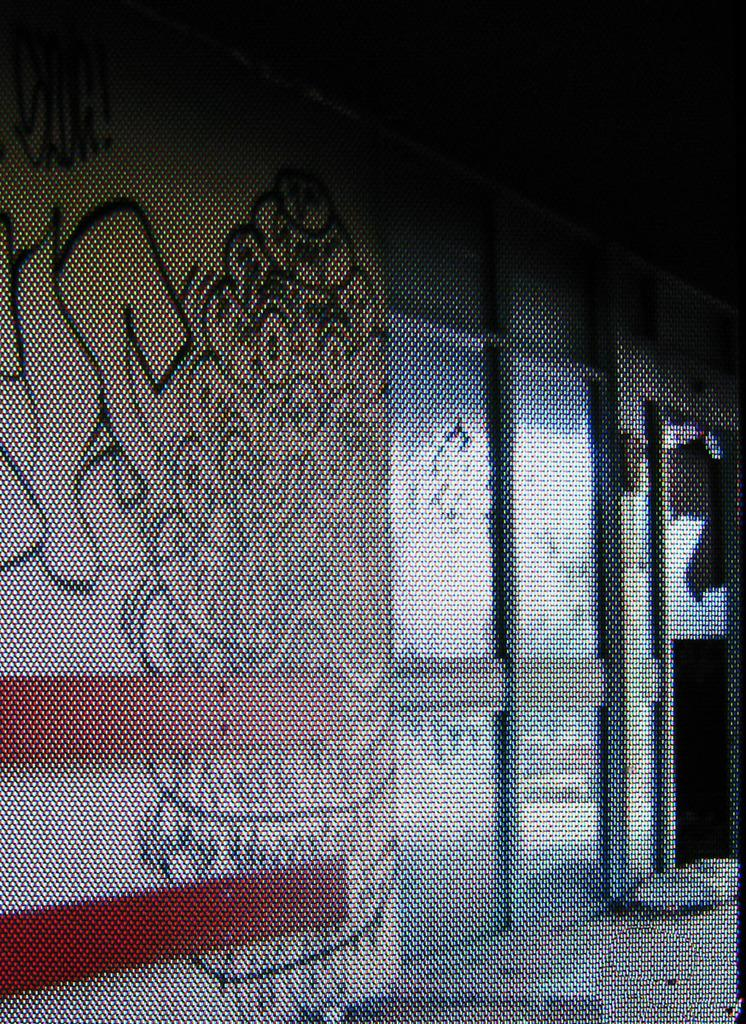What is depicted on the wall in the image? There is a painting on the wall in the image. What type of objects are the glasses in the image? The glasses are objects in the image. What type of sail can be seen in the painting on the wall? There is no sail present in the image, as the painting on the wall is not described in detail. What form does the snow take in the image? There is no snow present in the image. 